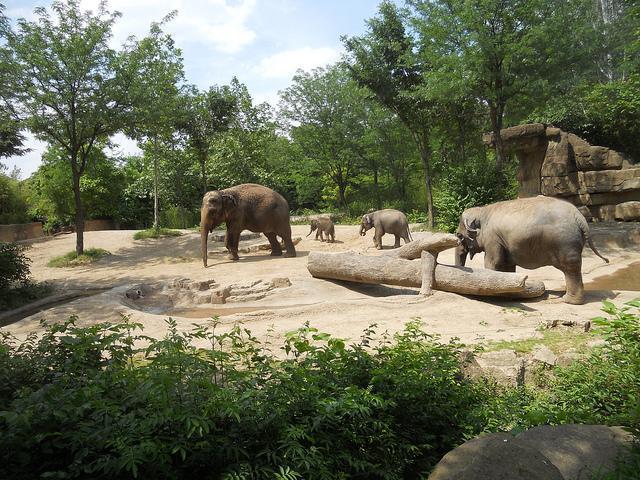How many elephants?
Give a very brief answer. 4. How many elephants are there?
Give a very brief answer. 2. How many men are in the picture?
Give a very brief answer. 0. 